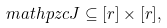<formula> <loc_0><loc_0><loc_500><loc_500>\ m a t h p z c { J } \subseteq [ r ] \times [ r ] ,</formula> 